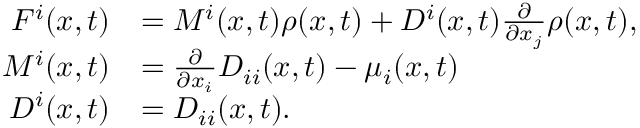<formula> <loc_0><loc_0><loc_500><loc_500>\begin{array} { r l } { F ^ { i } ( x , t ) } & { = M ^ { i } ( x , t ) \rho ( x , t ) + D ^ { i } ( x , t ) \frac { \partial } { \partial x _ { j } } \rho ( x , t ) , } \\ { M ^ { i } ( x , t ) } & { = \frac { \partial } { \partial x _ { i } } D _ { i i } ( x , t ) - \mu _ { i } ( x , t ) } \\ { D ^ { i } ( x , t ) } & { = D _ { i i } ( x , t ) . } \end{array}</formula> 